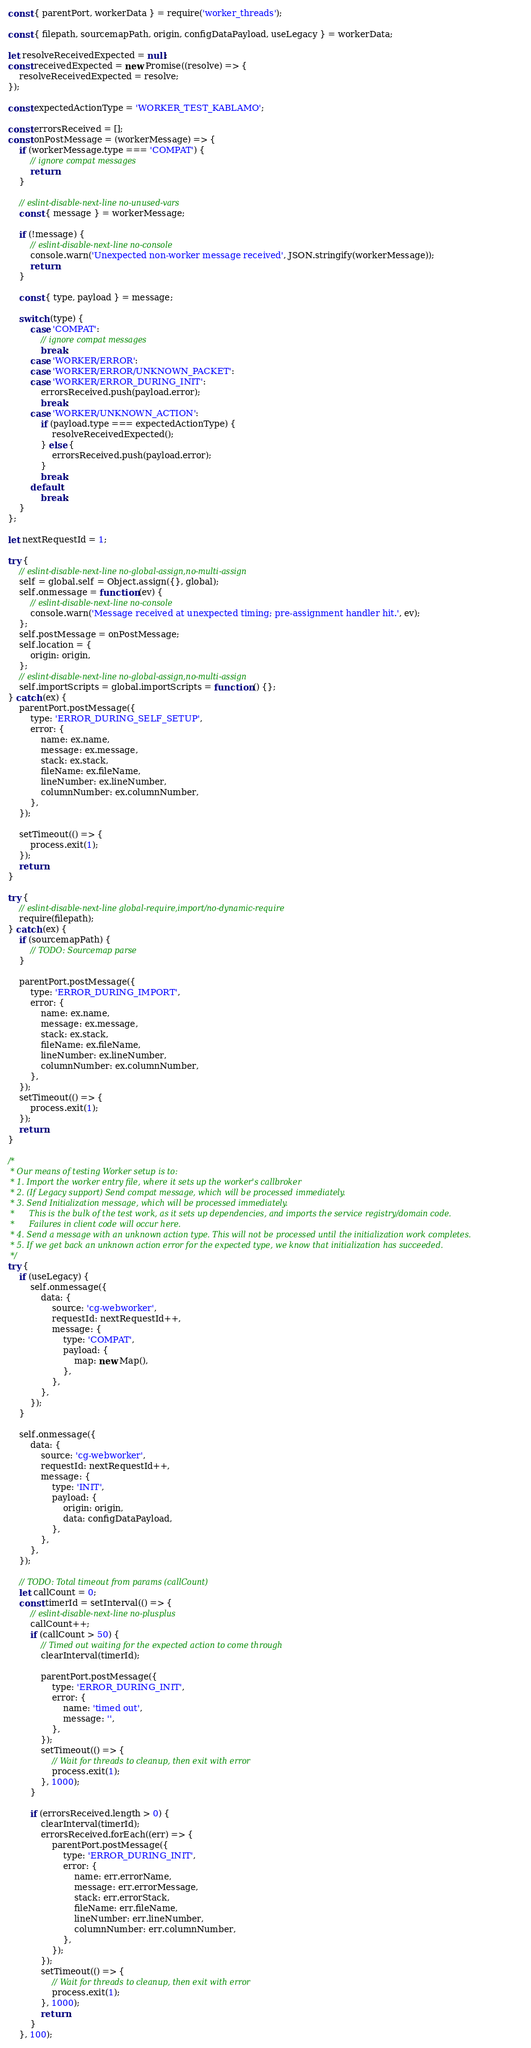Convert code to text. <code><loc_0><loc_0><loc_500><loc_500><_JavaScript_>const { parentPort, workerData } = require('worker_threads');

const { filepath, sourcemapPath, origin, configDataPayload, useLegacy } = workerData;

let resolveReceivedExpected = null;
const receivedExpected = new Promise((resolve) => {
    resolveReceivedExpected = resolve;
});

const expectedActionType = 'WORKER_TEST_KABLAMO';

const errorsReceived = [];
const onPostMessage = (workerMessage) => {
    if (workerMessage.type === 'COMPAT') {
        // ignore compat messages
        return;
    }

    // eslint-disable-next-line no-unused-vars
    const { message } = workerMessage;

    if (!message) {
        // eslint-disable-next-line no-console
        console.warn('Unexpected non-worker message received', JSON.stringify(workerMessage));
        return;
    }

    const { type, payload } = message;

    switch (type) {
        case 'COMPAT':
            // ignore compat messages
            break;
        case 'WORKER/ERROR':
        case 'WORKER/ERROR/UNKNOWN_PACKET':
        case 'WORKER/ERROR_DURING_INIT':
            errorsReceived.push(payload.error);
            break;
        case 'WORKER/UNKNOWN_ACTION':
            if (payload.type === expectedActionType) {
                resolveReceivedExpected();
            } else {
                errorsReceived.push(payload.error);
            }
            break;
        default:
            break;
    }
};

let nextRequestId = 1;

try {
    // eslint-disable-next-line no-global-assign,no-multi-assign
    self = global.self = Object.assign({}, global);
    self.onmessage = function (ev) {
        // eslint-disable-next-line no-console
        console.warn('Message received at unexpected timing; pre-assignment handler hit.', ev);
    };
    self.postMessage = onPostMessage;
    self.location = {
        origin: origin,
    };
    // eslint-disable-next-line no-global-assign,no-multi-assign
    self.importScripts = global.importScripts = function () {};
} catch (ex) {
    parentPort.postMessage({
        type: 'ERROR_DURING_SELF_SETUP',
        error: {
            name: ex.name,
            message: ex.message,
            stack: ex.stack,
            fileName: ex.fileName,
            lineNumber: ex.lineNumber,
            columnNumber: ex.columnNumber,
        },
    });

    setTimeout(() => {
        process.exit(1);
    });
    return;
}

try {
    // eslint-disable-next-line global-require,import/no-dynamic-require
    require(filepath);
} catch (ex) {
    if (sourcemapPath) {
        // TODO: Sourcemap parse
    }

    parentPort.postMessage({
        type: 'ERROR_DURING_IMPORT',
        error: {
            name: ex.name,
            message: ex.message,
            stack: ex.stack,
            fileName: ex.fileName,
            lineNumber: ex.lineNumber,
            columnNumber: ex.columnNumber,
        },
    });
    setTimeout(() => {
        process.exit(1);
    });
    return;
}

/*
 * Our means of testing Worker setup is to:
 * 1. Import the worker entry file, where it sets up the worker's callbroker
 * 2. (If Legacy support) Send compat message, which will be processed immediately.
 * 3. Send Initialization message, which will be processed immediately.
 *      This is the bulk of the test work, as it sets up dependencies, and imports the service registry/domain code.
 *      Failures in client code will occur here.
 * 4. Send a message with an unknown action type. This will not be processed until the initialization work completes.
 * 5. If we get back an unknown action error for the expected type, we know that initialization has succeeded.
 */
try {
    if (useLegacy) {
        self.onmessage({
            data: {
                source: 'cg-webworker',
                requestId: nextRequestId++,
                message: {
                    type: 'COMPAT',
                    payload: {
                        map: new Map(),
                    },
                },
            },
        });
    }

    self.onmessage({
        data: {
            source: 'cg-webworker',
            requestId: nextRequestId++,
            message: {
                type: 'INIT',
                payload: {
                    origin: origin,
                    data: configDataPayload,
                },
            },
        },
    });

    // TODO: Total timeout from params (callCount)
    let callCount = 0;
    const timerId = setInterval(() => {
        // eslint-disable-next-line no-plusplus
        callCount++;
        if (callCount > 50) {
            // Timed out waiting for the expected action to come through
            clearInterval(timerId);

            parentPort.postMessage({
                type: 'ERROR_DURING_INIT',
                error: {
                    name: 'timed out',
                    message: '',
                },
            });
            setTimeout(() => {
                // Wait for threads to cleanup, then exit with error
                process.exit(1);
            }, 1000);
        }

        if (errorsReceived.length > 0) {
            clearInterval(timerId);
            errorsReceived.forEach((err) => {
                parentPort.postMessage({
                    type: 'ERROR_DURING_INIT',
                    error: {
                        name: err.errorName,
                        message: err.errorMessage,
                        stack: err.errorStack,
                        fileName: err.fileName,
                        lineNumber: err.lineNumber,
                        columnNumber: err.columnNumber,
                    },
                });
            });
            setTimeout(() => {
                // Wait for threads to cleanup, then exit with error
                process.exit(1);
            }, 1000);
            return;
        }
    }, 100);
</code> 